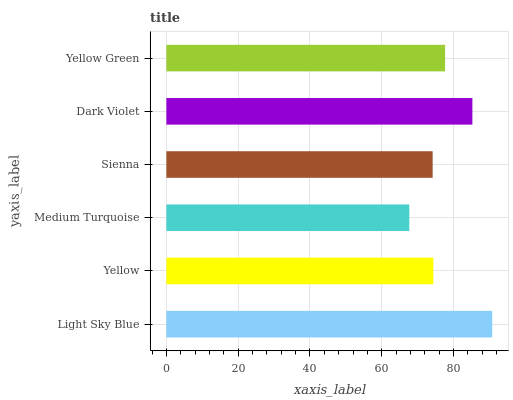Is Medium Turquoise the minimum?
Answer yes or no. Yes. Is Light Sky Blue the maximum?
Answer yes or no. Yes. Is Yellow the minimum?
Answer yes or no. No. Is Yellow the maximum?
Answer yes or no. No. Is Light Sky Blue greater than Yellow?
Answer yes or no. Yes. Is Yellow less than Light Sky Blue?
Answer yes or no. Yes. Is Yellow greater than Light Sky Blue?
Answer yes or no. No. Is Light Sky Blue less than Yellow?
Answer yes or no. No. Is Yellow Green the high median?
Answer yes or no. Yes. Is Yellow the low median?
Answer yes or no. Yes. Is Dark Violet the high median?
Answer yes or no. No. Is Dark Violet the low median?
Answer yes or no. No. 